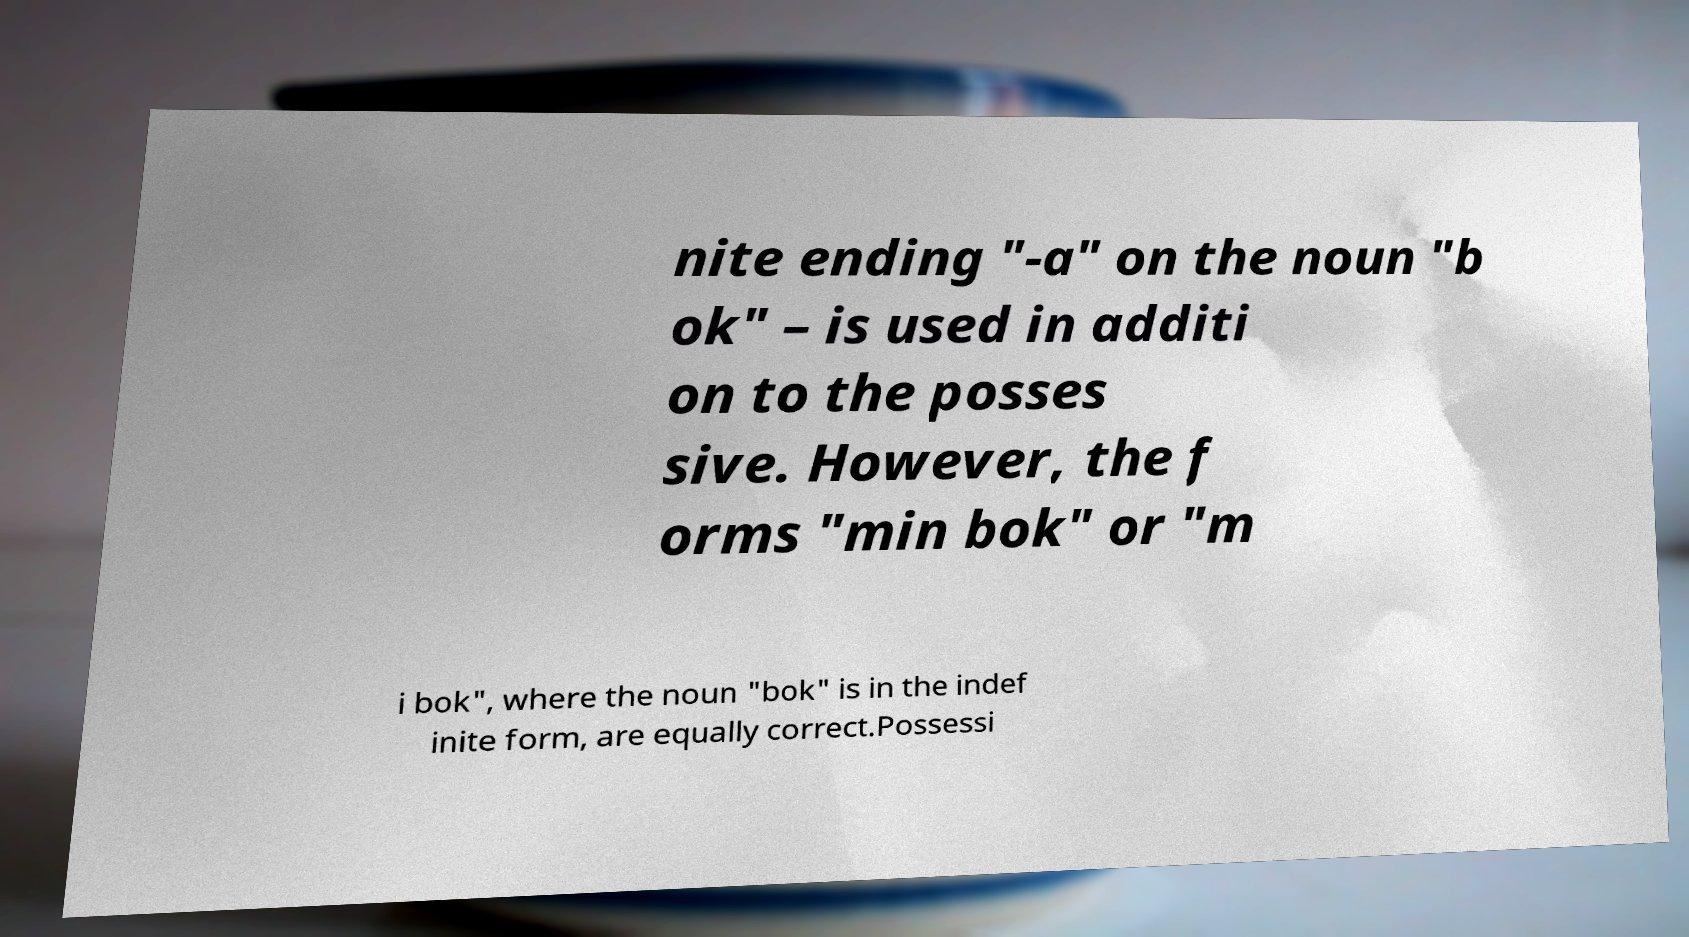Please read and relay the text visible in this image. What does it say? nite ending "-a" on the noun "b ok" – is used in additi on to the posses sive. However, the f orms "min bok" or "m i bok", where the noun "bok" is in the indef inite form, are equally correct.Possessi 